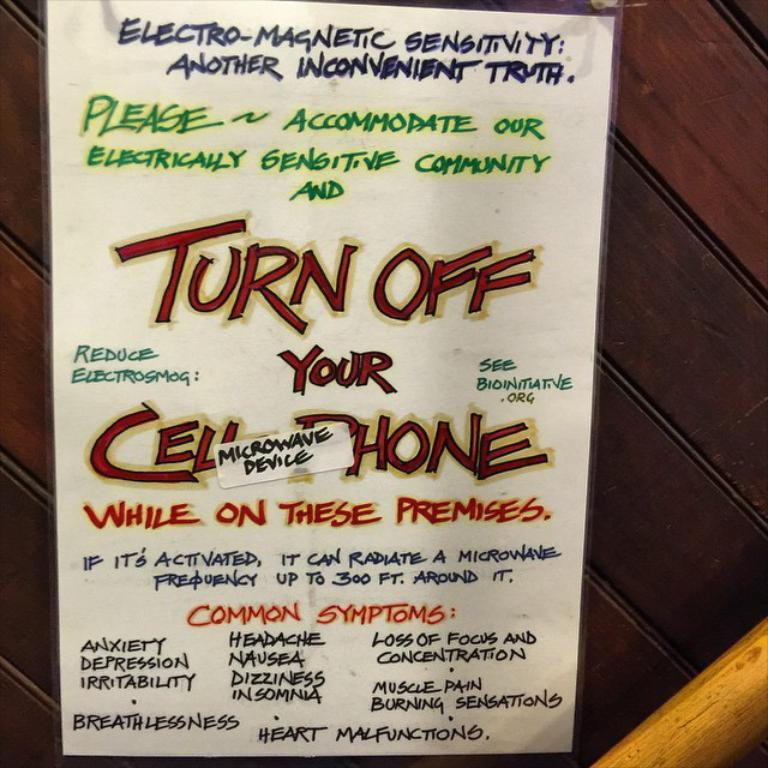<image>
Provide a brief description of the given image. Sign on a wall that tells people to turn off their microwave device. 